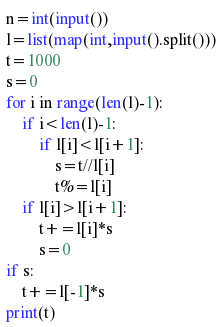<code> <loc_0><loc_0><loc_500><loc_500><_Python_>n=int(input())
l=list(map(int,input().split()))
t=1000
s=0
for i in range(len(l)-1):
	if i<len(l)-1:
		if l[i]<l[i+1]:
			s=t//l[i]
			t%=l[i]
	if l[i]>l[i+1]:
		t+=l[i]*s
		s=0
if s:
	t+=l[-1]*s
print(t)
</code> 